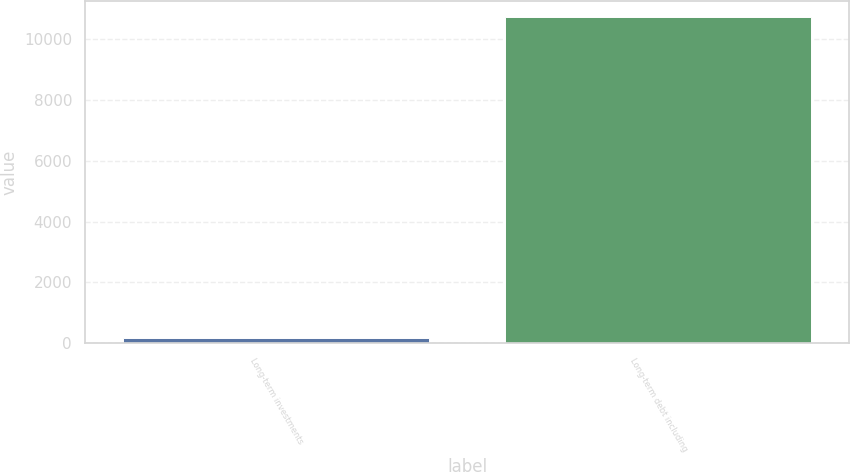<chart> <loc_0><loc_0><loc_500><loc_500><bar_chart><fcel>Long-term investments<fcel>Long-term debt including<nl><fcel>174<fcel>10734<nl></chart> 